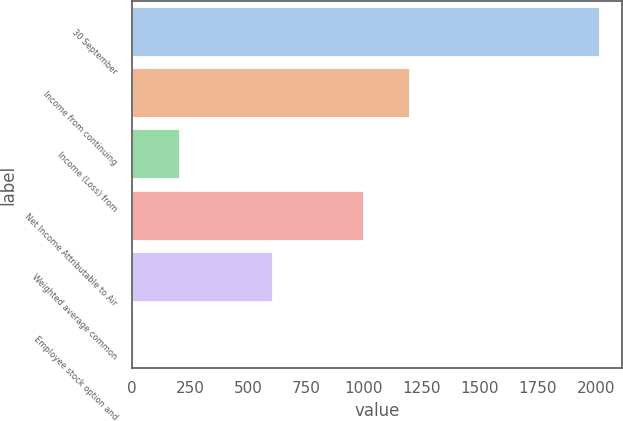Convert chart to OTSL. <chart><loc_0><loc_0><loc_500><loc_500><bar_chart><fcel>30 September<fcel>Income from continuing<fcel>Income (Loss) from<fcel>Net Income Attributable to Air<fcel>Weighted average common<fcel>Employee stock option and<nl><fcel>2013<fcel>1195.24<fcel>203.64<fcel>994.2<fcel>605.72<fcel>2.6<nl></chart> 